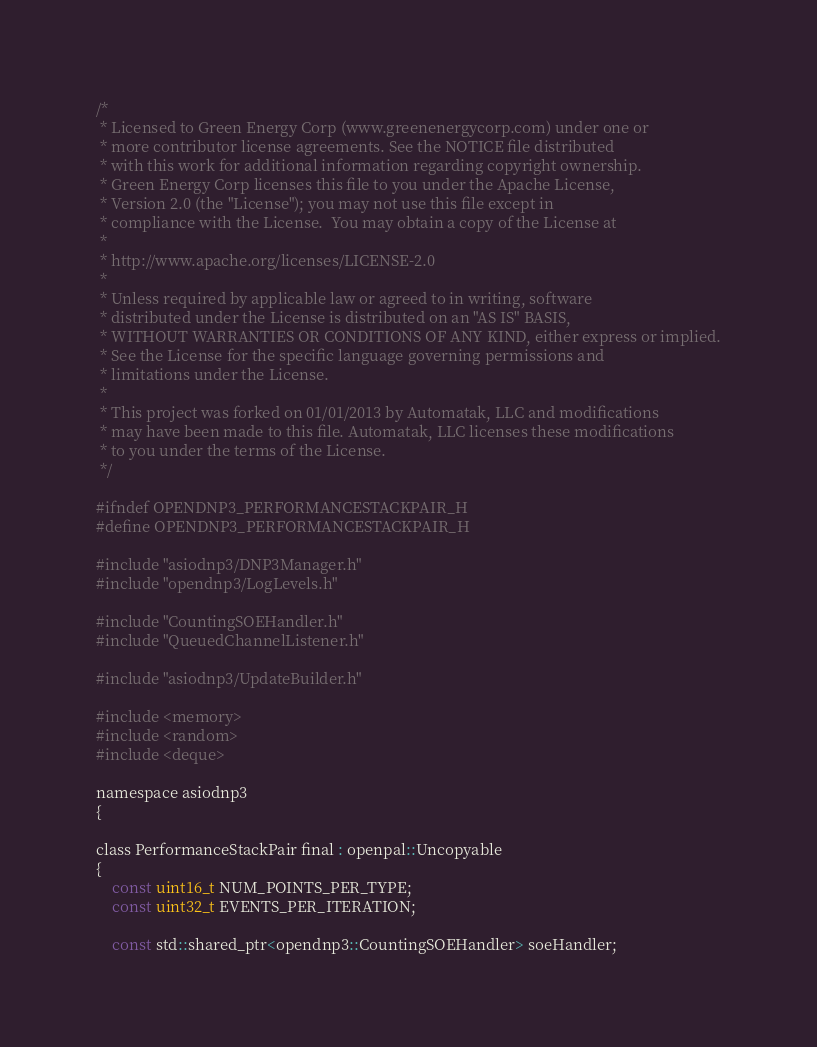<code> <loc_0><loc_0><loc_500><loc_500><_C_>/*
 * Licensed to Green Energy Corp (www.greenenergycorp.com) under one or
 * more contributor license agreements. See the NOTICE file distributed
 * with this work for additional information regarding copyright ownership.
 * Green Energy Corp licenses this file to you under the Apache License,
 * Version 2.0 (the "License"); you may not use this file except in
 * compliance with the License.  You may obtain a copy of the License at
 *
 * http://www.apache.org/licenses/LICENSE-2.0
 *
 * Unless required by applicable law or agreed to in writing, software
 * distributed under the License is distributed on an "AS IS" BASIS,
 * WITHOUT WARRANTIES OR CONDITIONS OF ANY KIND, either express or implied.
 * See the License for the specific language governing permissions and
 * limitations under the License.
 *
 * This project was forked on 01/01/2013 by Automatak, LLC and modifications
 * may have been made to this file. Automatak, LLC licenses these modifications
 * to you under the terms of the License.
 */

#ifndef OPENDNP3_PERFORMANCESTACKPAIR_H
#define OPENDNP3_PERFORMANCESTACKPAIR_H

#include "asiodnp3/DNP3Manager.h"
#include "opendnp3/LogLevels.h"

#include "CountingSOEHandler.h"
#include "QueuedChannelListener.h"

#include "asiodnp3/UpdateBuilder.h"

#include <memory>
#include <random>
#include <deque>

namespace asiodnp3
{

class PerformanceStackPair final : openpal::Uncopyable
{
	const uint16_t NUM_POINTS_PER_TYPE;
	const uint32_t EVENTS_PER_ITERATION;

	const std::shared_ptr<opendnp3::CountingSOEHandler> soeHandler;
</code> 